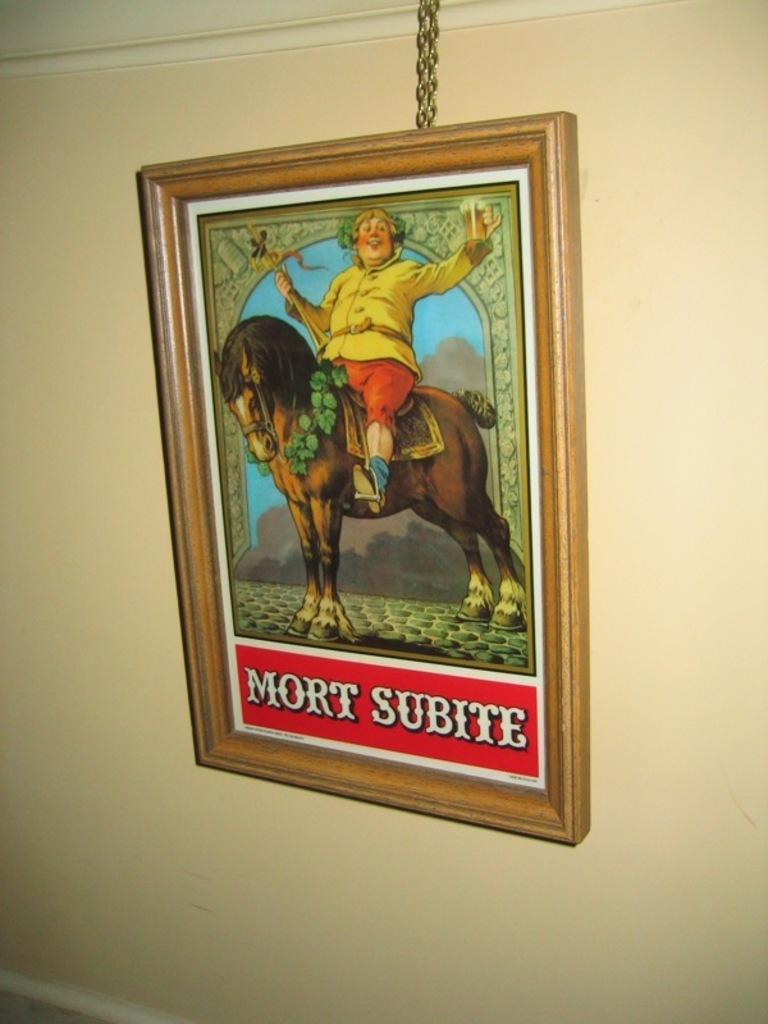Can you describe this image briefly? In this picture I can see the wall in front, on which there is a photo frame and I can see the depiction of a horse and a person sitting on it and I see the person is holding a glass and other thing and I see something is written on the bottom of the photo frame. On the top of this picture I can see the chains. 